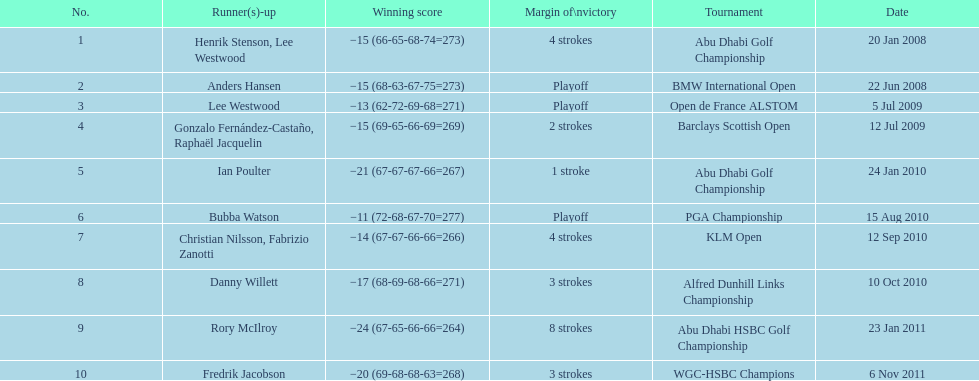How many tournaments has he won by 3 or more strokes? 5. 